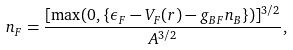Convert formula to latex. <formula><loc_0><loc_0><loc_500><loc_500>n _ { F } = \frac { [ \max ( 0 , \{ \epsilon _ { F } - V _ { F } ( { r } ) - g _ { B F } n _ { B } \} ) ] ^ { 3 / 2 } } { A ^ { 3 / 2 } } ,</formula> 